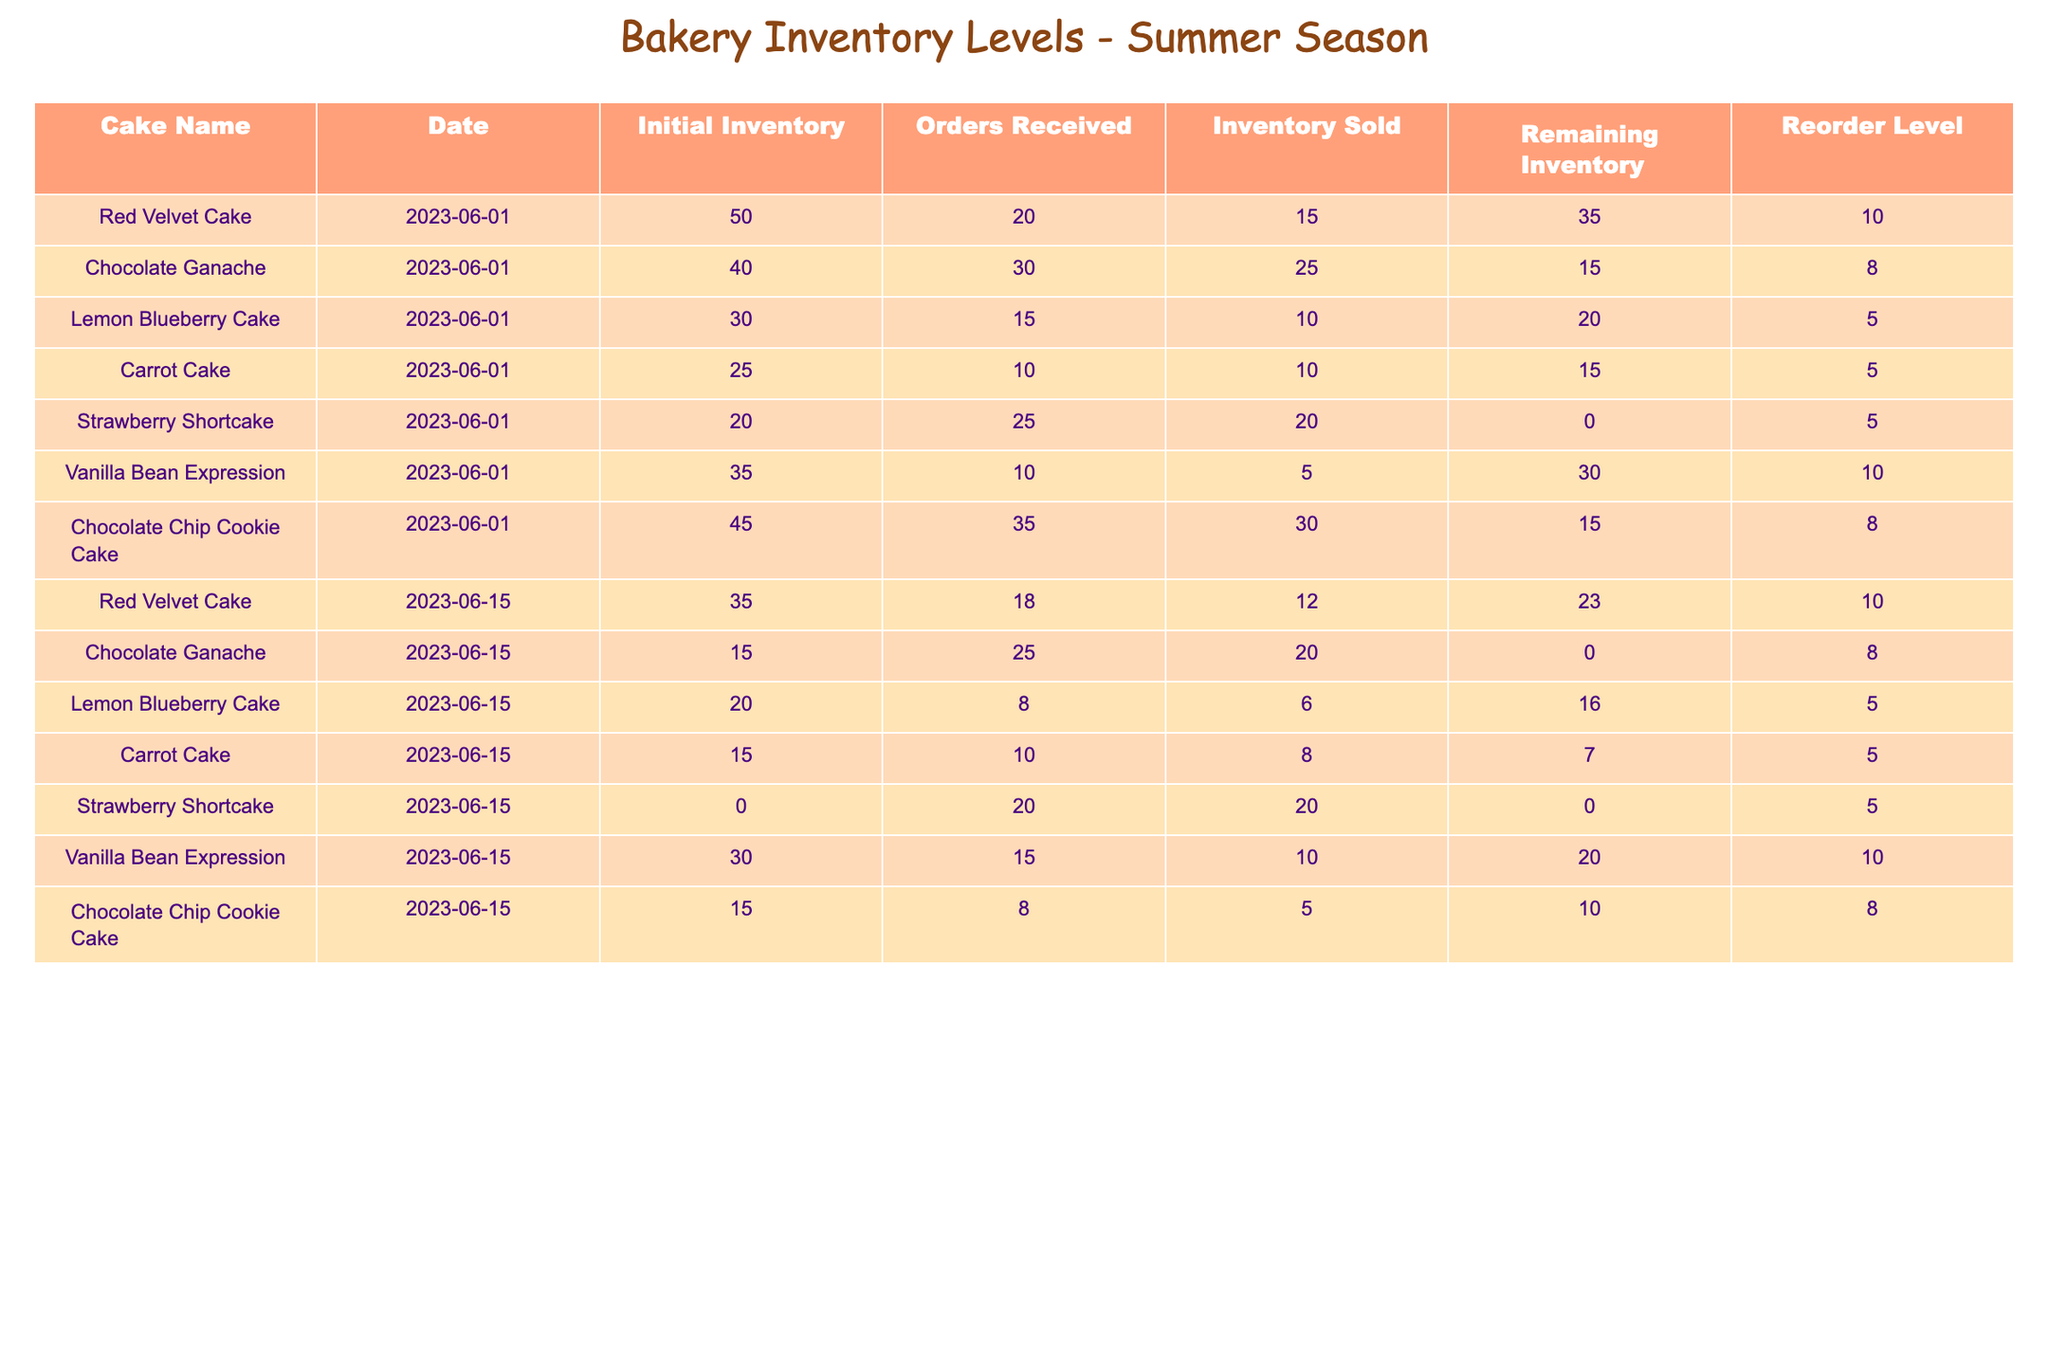What is the remaining inventory of the Strawberry Shortcake on June 1? On June 1, the Strawberry Shortcake has a remaining inventory of 0. This is directly listed in the table under the "Remaining Inventory" column for the corresponding date.
Answer: 0 What is the reorder level for the Chocolate Ganache cake? The reorder level for the Chocolate Ganache cake is found in the "Reorder Level" column. For June 1, it is listed as 8.
Answer: 8 How many more orders were received for Red Velvet Cake than for Carrot Cake on June 15? On June 15, the Red Velvet Cake received 18 orders, while the Carrot Cake received 10 orders. Subtracting the two gives 18 - 10 = 8 more orders for Red Velvet Cake.
Answer: 8 What was the total inventory sold across all cakes by June 1? By June 1, the inventory sold can be found by summing the "Inventory Sold" column: 15 (Red Velvet) + 25 (Chocolate Ganache) + 10 (Lemon Blueberry) + 10 (Carrot Cake) + 20 (Strawberry Shortcake) + 5 (Vanilla Bean) + 30 (Chocolate Chip Cookie) = 115.
Answer: 115 Is there sufficient inventory to meet the reorder levels for the Vanilla Bean Expression on June 15? On June 15, the remaining inventory for the Vanilla Bean Expression is 20, and its reorder level is 10. Since 20 is greater than 10, there is sufficient inventory.
Answer: Yes What is the average remaining inventory of all cake types on June 15? The remaining inventories on June 15 are: 23 (Red Velvet), 0 (Chocolate Ganache), 16 (Lemon Blueberry), 7 (Carrot Cake), 0 (Strawberry Shortcake), 20 (Vanilla Bean), and 10 (Chocolate Chip Cookie). Summing these gives 76, and dividing by the 7 cake types gives an average of 76 / 7 ≈ 10.86.
Answer: Approximately 10.86 How many cakes had a remaining inventory of 0 on June 15? Looking at the "Remaining Inventory" column for June 15, both the Chocolate Ganache and Strawberry Shortcake show 0 remaining inventory, thus there are 2 cakes with 0 remaining.
Answer: 2 Was the inventory sold for Lemon Blueberry Cake higher on June 1 or June 15? On June 1, the Lemon Blueberry Cake had 10 sold, whereas on June 15 it had 6 sold. Since 10 > 6, more was sold on June 1.
Answer: June 1 